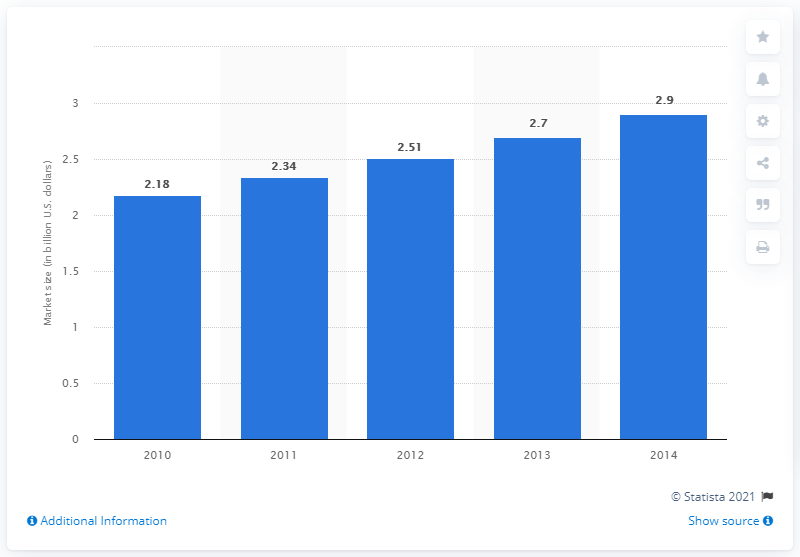Specify some key components in this picture. In 2011, the projected volume of the Asian language services market was 2.34... 